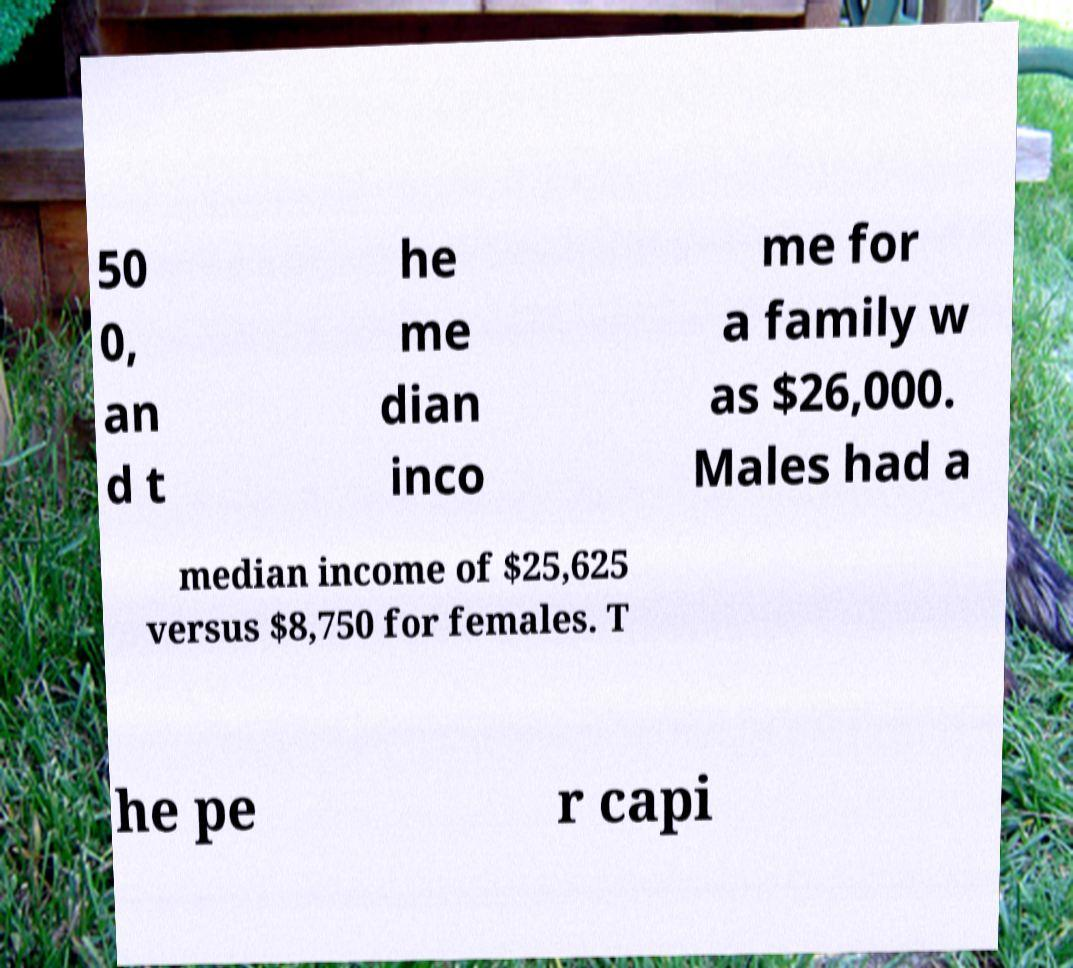Can you accurately transcribe the text from the provided image for me? 50 0, an d t he me dian inco me for a family w as $26,000. Males had a median income of $25,625 versus $8,750 for females. T he pe r capi 